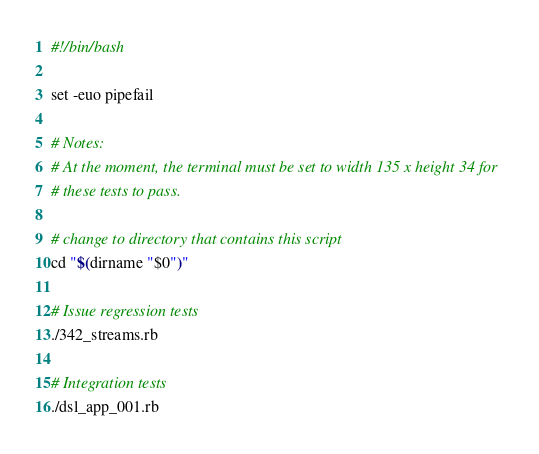Convert code to text. <code><loc_0><loc_0><loc_500><loc_500><_Bash_>#!/bin/bash

set -euo pipefail

# Notes:
# At the moment, the terminal must be set to width 135 x height 34 for
# these tests to pass.

# change to directory that contains this script
cd "$(dirname "$0")"

# Issue regression tests
./342_streams.rb

# Integration tests
./dsl_app_001.rb</code> 